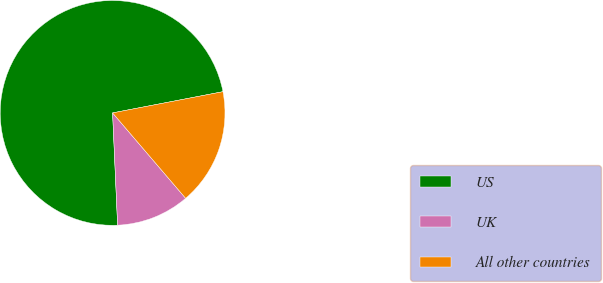<chart> <loc_0><loc_0><loc_500><loc_500><pie_chart><fcel>US<fcel>UK<fcel>All other countries<nl><fcel>72.68%<fcel>10.55%<fcel>16.76%<nl></chart> 